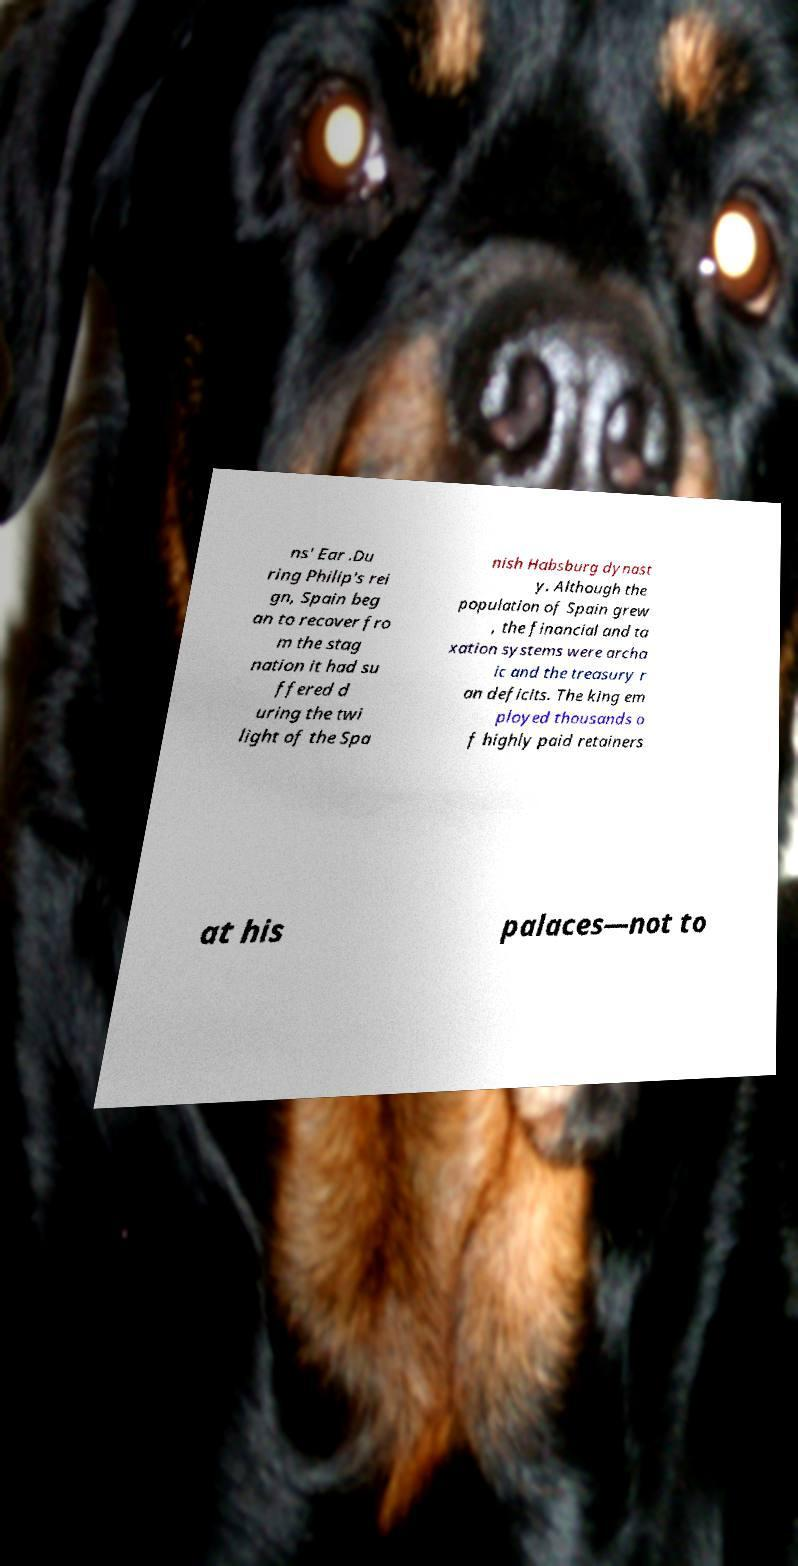There's text embedded in this image that I need extracted. Can you transcribe it verbatim? ns' Ear .Du ring Philip's rei gn, Spain beg an to recover fro m the stag nation it had su ffered d uring the twi light of the Spa nish Habsburg dynast y. Although the population of Spain grew , the financial and ta xation systems were archa ic and the treasury r an deficits. The king em ployed thousands o f highly paid retainers at his palaces—not to 